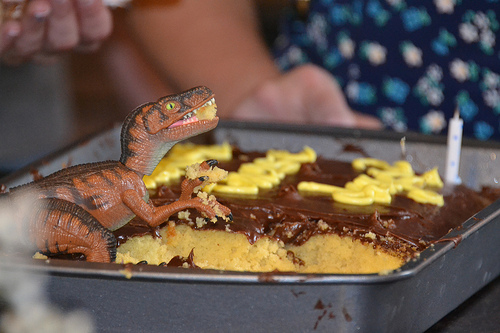<image>
Is the dinosaur in the cake? Yes. The dinosaur is contained within or inside the cake, showing a containment relationship. Where is the dinosaur in relation to the pan? Is it in the pan? Yes. The dinosaur is contained within or inside the pan, showing a containment relationship. Where is the dinosaur in relation to the cake? Is it above the cake? Yes. The dinosaur is positioned above the cake in the vertical space, higher up in the scene. 